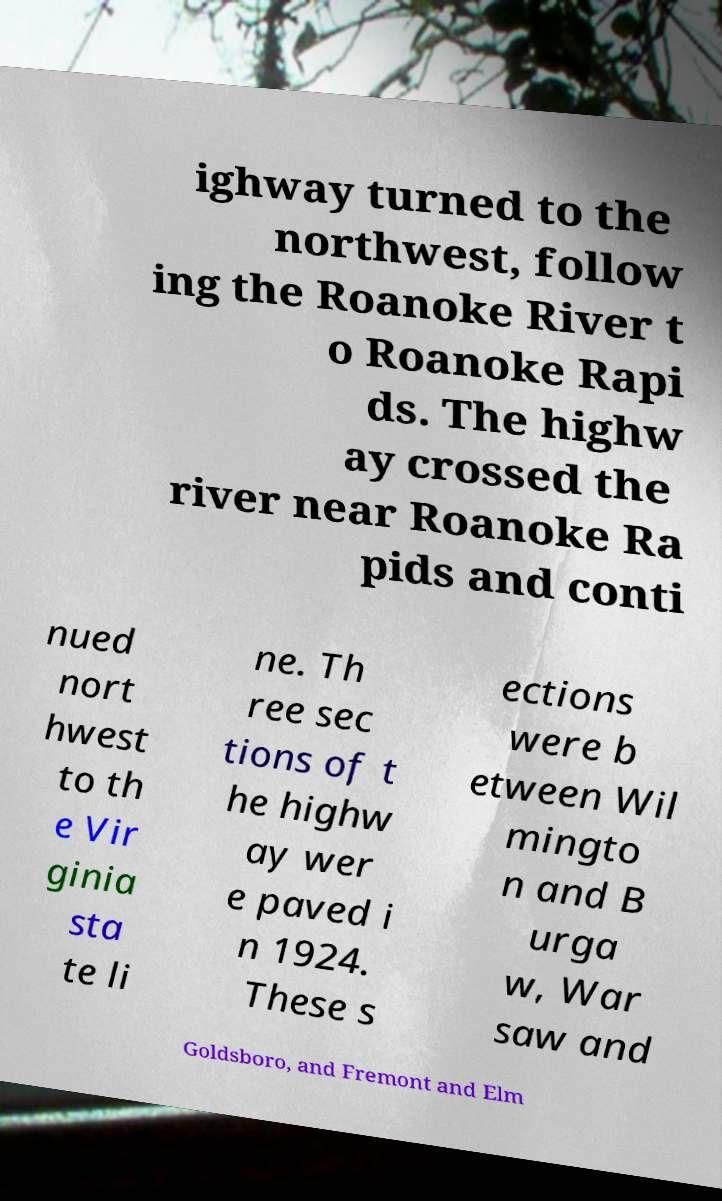Could you extract and type out the text from this image? ighway turned to the northwest, follow ing the Roanoke River t o Roanoke Rapi ds. The highw ay crossed the river near Roanoke Ra pids and conti nued nort hwest to th e Vir ginia sta te li ne. Th ree sec tions of t he highw ay wer e paved i n 1924. These s ections were b etween Wil mingto n and B urga w, War saw and Goldsboro, and Fremont and Elm 